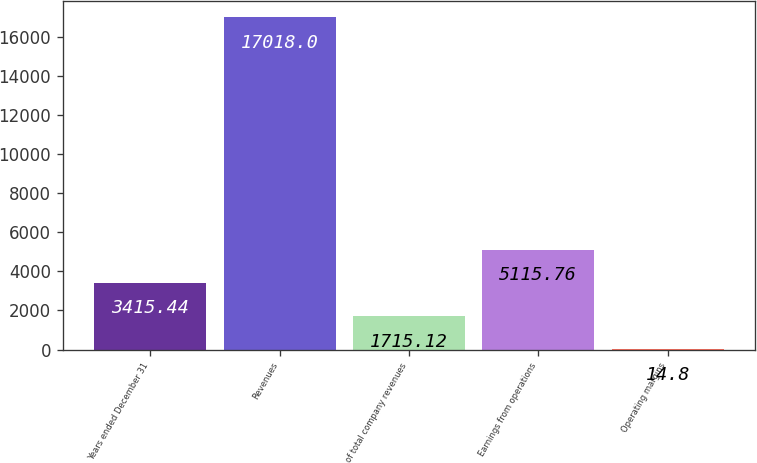<chart> <loc_0><loc_0><loc_500><loc_500><bar_chart><fcel>Years ended December 31<fcel>Revenues<fcel>of total company revenues<fcel>Earnings from operations<fcel>Operating margins<nl><fcel>3415.44<fcel>17018<fcel>1715.12<fcel>5115.76<fcel>14.8<nl></chart> 